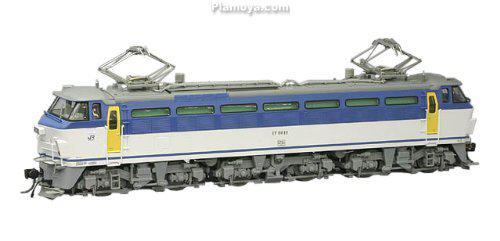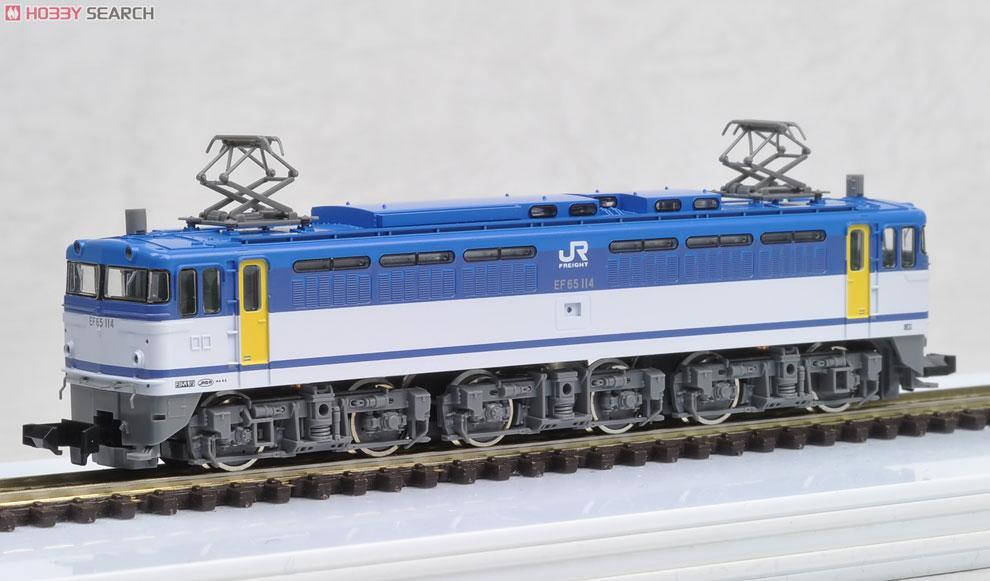The first image is the image on the left, the second image is the image on the right. Assess this claim about the two images: "Power lines can be seen above the train in the image on the right.". Correct or not? Answer yes or no. No. 